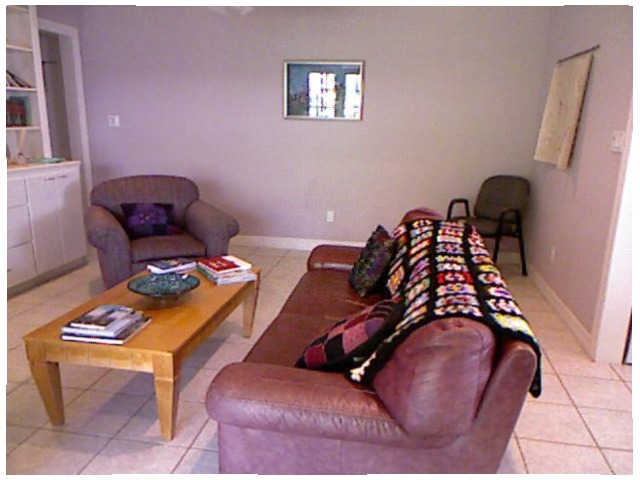<image>
Can you confirm if the table is in front of the sofa? Yes. The table is positioned in front of the sofa, appearing closer to the camera viewpoint. 